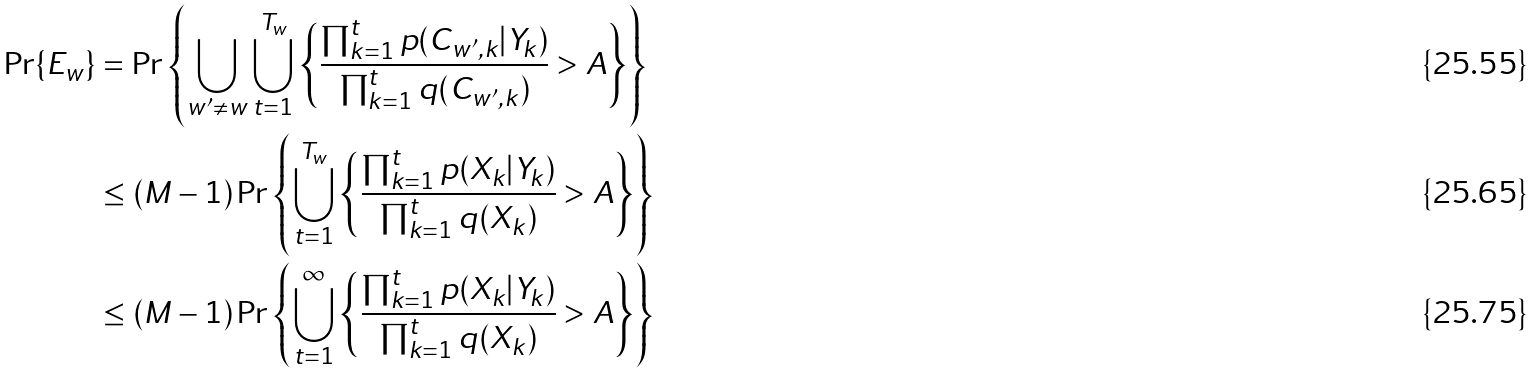<formula> <loc_0><loc_0><loc_500><loc_500>\Pr \{ E _ { w } \} & = \Pr \left \{ \bigcup _ { w ^ { \prime } \neq w } \bigcup _ { t = 1 } ^ { T _ { w } } \left \{ \frac { \prod _ { k = 1 } ^ { t } p ( C _ { w ^ { \prime } , k } | Y _ { k } ) } { \prod _ { k = 1 } ^ { t } q ( C _ { w ^ { \prime } , k } ) } > A \right \} \right \} \\ & \leq ( M - 1 ) \Pr \left \{ \bigcup _ { t = 1 } ^ { T _ { w } } \left \{ \frac { \prod _ { k = 1 } ^ { t } p ( X _ { k } | Y _ { k } ) } { \prod _ { k = 1 } ^ { t } q ( X _ { k } ) } > A \right \} \right \} \\ & \leq ( M - 1 ) \Pr \left \{ \bigcup _ { t = 1 } ^ { \infty } \left \{ \frac { \prod _ { k = 1 } ^ { t } p ( X _ { k } | Y _ { k } ) } { \prod _ { k = 1 } ^ { t } q ( X _ { k } ) } > A \right \} \right \}</formula> 